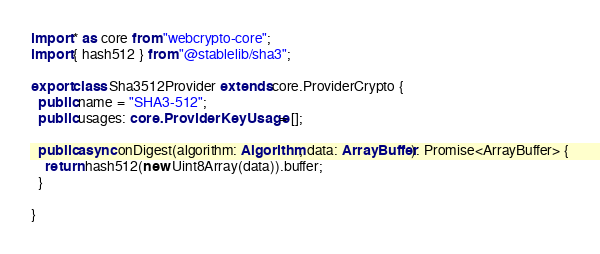<code> <loc_0><loc_0><loc_500><loc_500><_TypeScript_>import * as core from "webcrypto-core";
import { hash512 } from "@stablelib/sha3";

export class Sha3512Provider extends core.ProviderCrypto {
  public name = "SHA3-512";
  public usages: core.ProviderKeyUsage = [];

  public async onDigest(algorithm: Algorithm, data: ArrayBuffer): Promise<ArrayBuffer> {
    return hash512(new Uint8Array(data)).buffer;
  }

}
</code> 